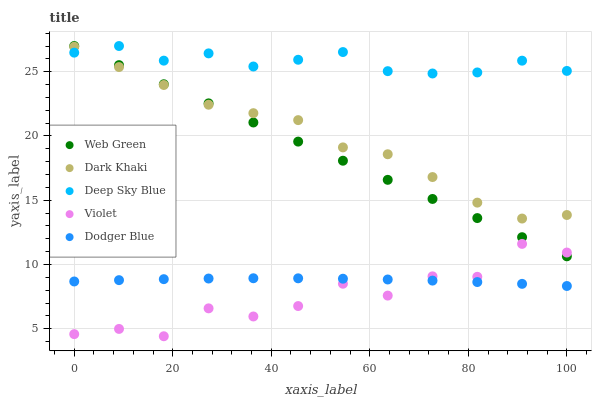Does Violet have the minimum area under the curve?
Answer yes or no. Yes. Does Deep Sky Blue have the maximum area under the curve?
Answer yes or no. Yes. Does Dodger Blue have the minimum area under the curve?
Answer yes or no. No. Does Dodger Blue have the maximum area under the curve?
Answer yes or no. No. Is Web Green the smoothest?
Answer yes or no. Yes. Is Violet the roughest?
Answer yes or no. Yes. Is Dodger Blue the smoothest?
Answer yes or no. No. Is Dodger Blue the roughest?
Answer yes or no. No. Does Violet have the lowest value?
Answer yes or no. Yes. Does Dodger Blue have the lowest value?
Answer yes or no. No. Does Web Green have the highest value?
Answer yes or no. Yes. Does Dodger Blue have the highest value?
Answer yes or no. No. Is Dodger Blue less than Web Green?
Answer yes or no. Yes. Is Web Green greater than Dodger Blue?
Answer yes or no. Yes. Does Deep Sky Blue intersect Dark Khaki?
Answer yes or no. Yes. Is Deep Sky Blue less than Dark Khaki?
Answer yes or no. No. Is Deep Sky Blue greater than Dark Khaki?
Answer yes or no. No. Does Dodger Blue intersect Web Green?
Answer yes or no. No. 